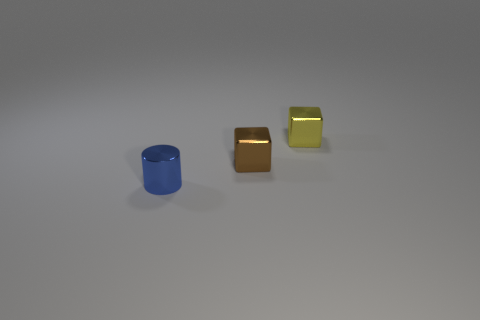The tiny cylinder is what color?
Offer a terse response. Blue. There is a small block behind the small brown shiny thing; what is its color?
Make the answer very short. Yellow. There is a object that is behind the brown object; what number of tiny metal blocks are in front of it?
Your answer should be compact. 1. There is a blue metal object; does it have the same size as the metallic object that is right of the small brown metal cube?
Keep it short and to the point. Yes. Are there any things that have the same size as the yellow block?
Provide a succinct answer. Yes. What number of things are either tiny brown metal cylinders or small brown shiny objects?
Offer a very short reply. 1. There is a cube behind the tiny brown metal cube; does it have the same size as the thing to the left of the brown thing?
Keep it short and to the point. Yes. Are there any other things of the same shape as the yellow thing?
Offer a terse response. Yes. Is the number of yellow cubes that are in front of the yellow thing less than the number of yellow metal things?
Your answer should be very brief. Yes. Is the shape of the tiny yellow shiny object the same as the brown metallic thing?
Provide a short and direct response. Yes. 